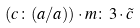<formula> <loc_0><loc_0><loc_500><loc_500>( c \colon ( a / a ) ) \cdot m \colon 3 \cdot \tilde { c }</formula> 